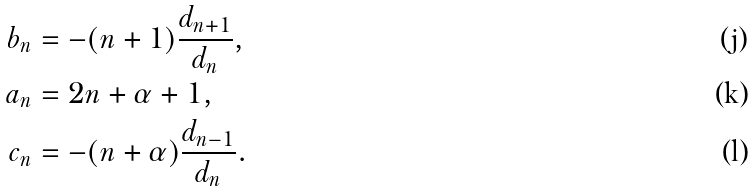<formula> <loc_0><loc_0><loc_500><loc_500>b _ { n } & = - ( n + 1 ) \frac { d _ { n + 1 } } { d _ { n } } , \\ a _ { n } & = 2 n + \alpha + 1 , \\ c _ { n } & = - ( n + \alpha ) \frac { d _ { n - 1 } } { d _ { n } } .</formula> 